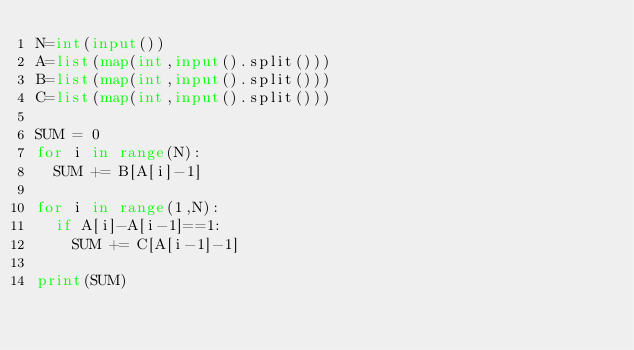Convert code to text. <code><loc_0><loc_0><loc_500><loc_500><_Python_>N=int(input())
A=list(map(int,input().split()))
B=list(map(int,input().split()))
C=list(map(int,input().split()))

SUM = 0
for i in range(N):
  SUM += B[A[i]-1]
  
for i in range(1,N):
  if A[i]-A[i-1]==1:
    SUM += C[A[i-1]-1]

print(SUM)</code> 